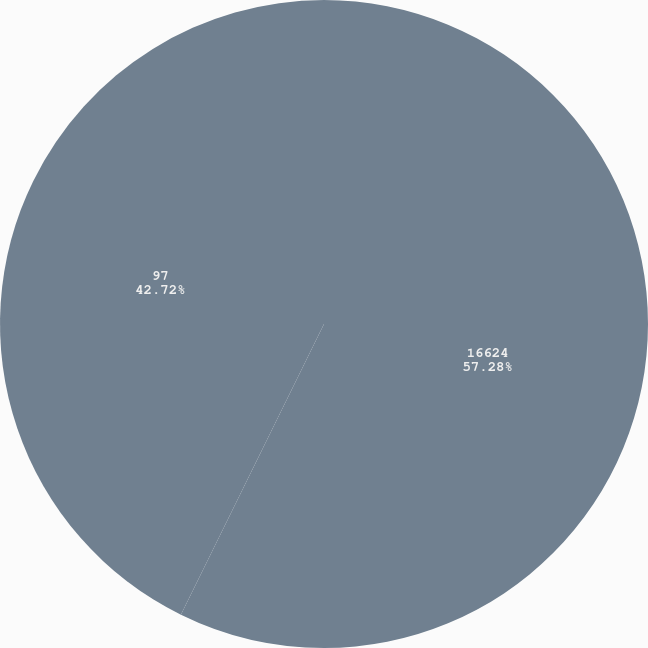Convert chart. <chart><loc_0><loc_0><loc_500><loc_500><pie_chart><fcel>16624<fcel>97<nl><fcel>57.28%<fcel>42.72%<nl></chart> 